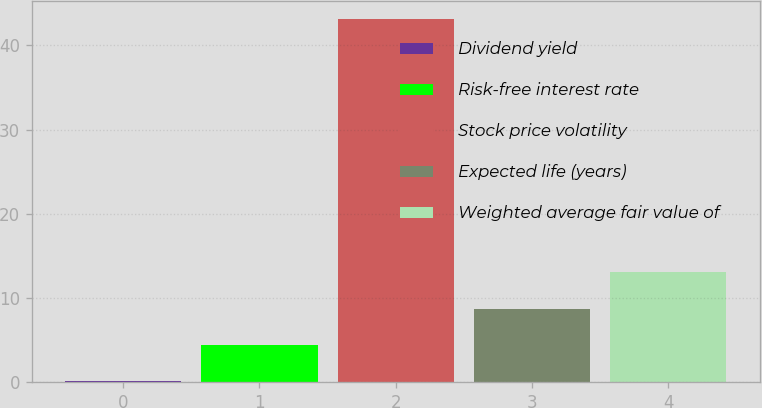<chart> <loc_0><loc_0><loc_500><loc_500><bar_chart><fcel>Dividend yield<fcel>Risk-free interest rate<fcel>Stock price volatility<fcel>Expected life (years)<fcel>Weighted average fair value of<nl><fcel>0.13<fcel>4.43<fcel>43.1<fcel>8.73<fcel>13.03<nl></chart> 